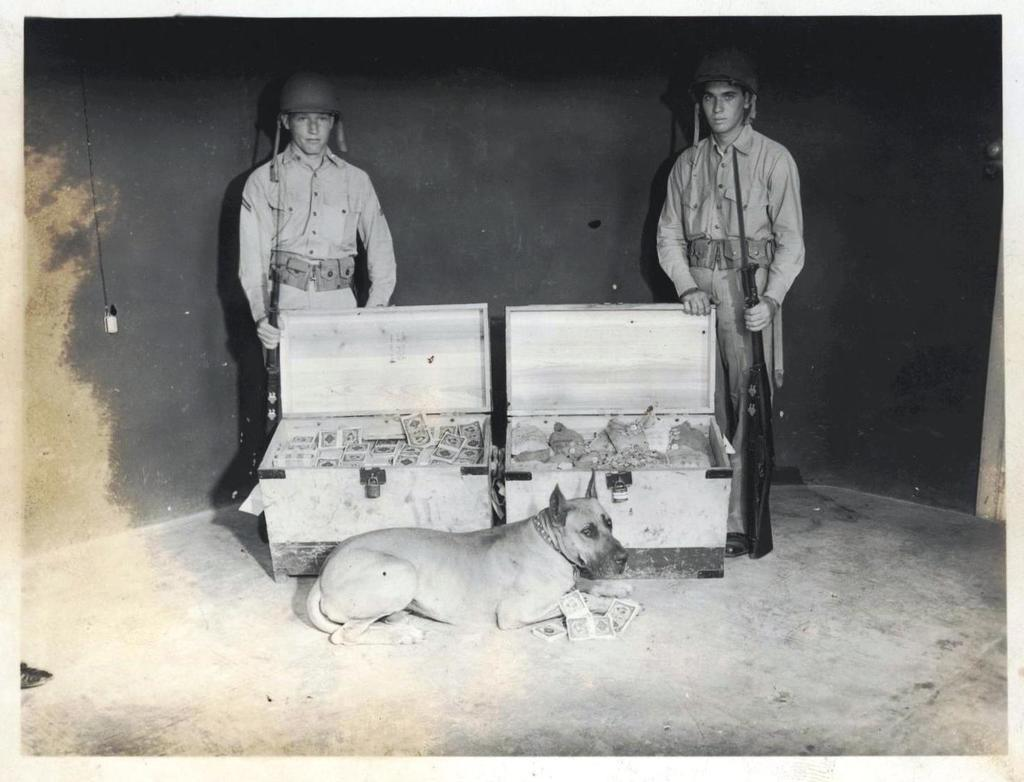What is the main subject in the middle of the image? There is a dog in the middle of the image. What can be seen behind the dog? There are boxes behind the dog. Who is standing behind the boxes in the image? Two persons are standing behind the boxes. What are the persons holding in their hands? The persons are holding weapons. What is visible behind the persons? There is a wall behind the persons. What type of ghost can be seen interacting with the dog in the image? There is no ghost present in the image; it features a dog, boxes, two persons holding weapons, and a wall. 